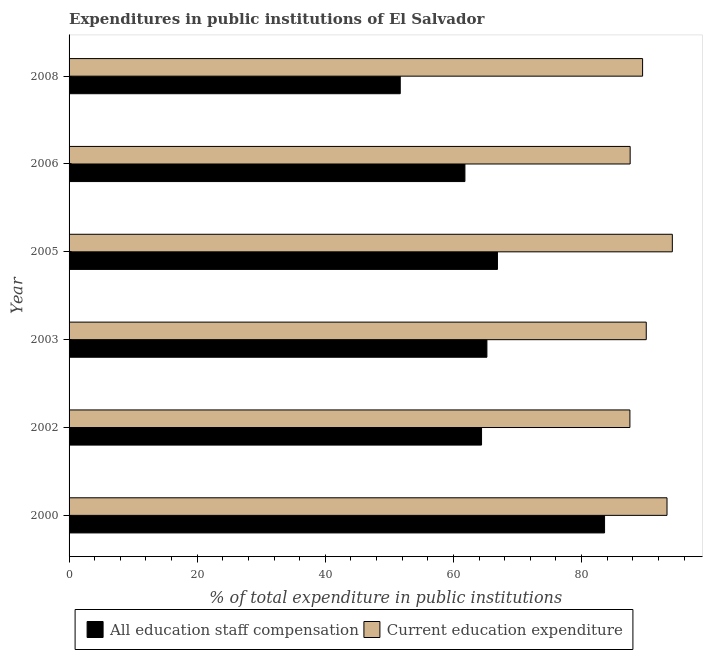How many different coloured bars are there?
Offer a very short reply. 2. Are the number of bars on each tick of the Y-axis equal?
Your answer should be compact. Yes. How many bars are there on the 3rd tick from the top?
Your response must be concise. 2. What is the label of the 5th group of bars from the top?
Your answer should be very brief. 2002. In how many cases, is the number of bars for a given year not equal to the number of legend labels?
Offer a terse response. 0. What is the expenditure in education in 2002?
Give a very brief answer. 87.54. Across all years, what is the maximum expenditure in staff compensation?
Make the answer very short. 83.58. Across all years, what is the minimum expenditure in staff compensation?
Your answer should be very brief. 51.69. In which year was the expenditure in staff compensation maximum?
Your response must be concise. 2000. In which year was the expenditure in education minimum?
Your answer should be very brief. 2002. What is the total expenditure in staff compensation in the graph?
Provide a succinct answer. 393.53. What is the difference between the expenditure in education in 2000 and that in 2008?
Give a very brief answer. 3.81. What is the difference between the expenditure in education in 2003 and the expenditure in staff compensation in 2000?
Ensure brevity in your answer.  6.51. What is the average expenditure in staff compensation per year?
Ensure brevity in your answer.  65.59. In the year 2002, what is the difference between the expenditure in education and expenditure in staff compensation?
Your answer should be very brief. 23.16. In how many years, is the expenditure in staff compensation greater than 72 %?
Your response must be concise. 1. What is the ratio of the expenditure in staff compensation in 2000 to that in 2006?
Provide a short and direct response. 1.35. Is the expenditure in staff compensation in 2000 less than that in 2006?
Offer a terse response. No. Is the difference between the expenditure in education in 2002 and 2008 greater than the difference between the expenditure in staff compensation in 2002 and 2008?
Ensure brevity in your answer.  No. What is the difference between the highest and the second highest expenditure in education?
Give a very brief answer. 0.83. What is the difference between the highest and the lowest expenditure in education?
Provide a short and direct response. 6.62. Is the sum of the expenditure in staff compensation in 2005 and 2006 greater than the maximum expenditure in education across all years?
Your answer should be compact. Yes. What does the 2nd bar from the top in 2008 represents?
Keep it short and to the point. All education staff compensation. What does the 1st bar from the bottom in 2000 represents?
Your response must be concise. All education staff compensation. How many bars are there?
Ensure brevity in your answer.  12. What is the title of the graph?
Offer a very short reply. Expenditures in public institutions of El Salvador. Does "GDP at market prices" appear as one of the legend labels in the graph?
Your answer should be very brief. No. What is the label or title of the X-axis?
Your answer should be compact. % of total expenditure in public institutions. What is the label or title of the Y-axis?
Provide a short and direct response. Year. What is the % of total expenditure in public institutions in All education staff compensation in 2000?
Offer a terse response. 83.58. What is the % of total expenditure in public institutions in Current education expenditure in 2000?
Provide a succinct answer. 93.33. What is the % of total expenditure in public institutions in All education staff compensation in 2002?
Offer a very short reply. 64.38. What is the % of total expenditure in public institutions in Current education expenditure in 2002?
Provide a short and direct response. 87.54. What is the % of total expenditure in public institutions in All education staff compensation in 2003?
Your answer should be compact. 65.22. What is the % of total expenditure in public institutions of Current education expenditure in 2003?
Keep it short and to the point. 90.09. What is the % of total expenditure in public institutions in All education staff compensation in 2005?
Offer a terse response. 66.86. What is the % of total expenditure in public institutions of Current education expenditure in 2005?
Provide a short and direct response. 94.16. What is the % of total expenditure in public institutions in All education staff compensation in 2006?
Keep it short and to the point. 61.79. What is the % of total expenditure in public institutions of Current education expenditure in 2006?
Offer a very short reply. 87.58. What is the % of total expenditure in public institutions in All education staff compensation in 2008?
Your response must be concise. 51.69. What is the % of total expenditure in public institutions of Current education expenditure in 2008?
Your answer should be compact. 89.52. Across all years, what is the maximum % of total expenditure in public institutions of All education staff compensation?
Ensure brevity in your answer.  83.58. Across all years, what is the maximum % of total expenditure in public institutions in Current education expenditure?
Offer a very short reply. 94.16. Across all years, what is the minimum % of total expenditure in public institutions of All education staff compensation?
Your answer should be very brief. 51.69. Across all years, what is the minimum % of total expenditure in public institutions of Current education expenditure?
Keep it short and to the point. 87.54. What is the total % of total expenditure in public institutions of All education staff compensation in the graph?
Make the answer very short. 393.53. What is the total % of total expenditure in public institutions of Current education expenditure in the graph?
Your answer should be very brief. 542.21. What is the difference between the % of total expenditure in public institutions in All education staff compensation in 2000 and that in 2002?
Offer a very short reply. 19.2. What is the difference between the % of total expenditure in public institutions in Current education expenditure in 2000 and that in 2002?
Provide a succinct answer. 5.79. What is the difference between the % of total expenditure in public institutions in All education staff compensation in 2000 and that in 2003?
Give a very brief answer. 18.36. What is the difference between the % of total expenditure in public institutions in Current education expenditure in 2000 and that in 2003?
Ensure brevity in your answer.  3.24. What is the difference between the % of total expenditure in public institutions in All education staff compensation in 2000 and that in 2005?
Offer a very short reply. 16.72. What is the difference between the % of total expenditure in public institutions in Current education expenditure in 2000 and that in 2005?
Make the answer very short. -0.83. What is the difference between the % of total expenditure in public institutions in All education staff compensation in 2000 and that in 2006?
Your answer should be compact. 21.8. What is the difference between the % of total expenditure in public institutions in Current education expenditure in 2000 and that in 2006?
Your answer should be compact. 5.75. What is the difference between the % of total expenditure in public institutions of All education staff compensation in 2000 and that in 2008?
Offer a terse response. 31.89. What is the difference between the % of total expenditure in public institutions of Current education expenditure in 2000 and that in 2008?
Your answer should be very brief. 3.81. What is the difference between the % of total expenditure in public institutions of All education staff compensation in 2002 and that in 2003?
Offer a terse response. -0.84. What is the difference between the % of total expenditure in public institutions in Current education expenditure in 2002 and that in 2003?
Make the answer very short. -2.55. What is the difference between the % of total expenditure in public institutions of All education staff compensation in 2002 and that in 2005?
Your answer should be compact. -2.48. What is the difference between the % of total expenditure in public institutions in Current education expenditure in 2002 and that in 2005?
Offer a very short reply. -6.62. What is the difference between the % of total expenditure in public institutions in All education staff compensation in 2002 and that in 2006?
Offer a terse response. 2.59. What is the difference between the % of total expenditure in public institutions in Current education expenditure in 2002 and that in 2006?
Provide a short and direct response. -0.04. What is the difference between the % of total expenditure in public institutions of All education staff compensation in 2002 and that in 2008?
Make the answer very short. 12.69. What is the difference between the % of total expenditure in public institutions in Current education expenditure in 2002 and that in 2008?
Make the answer very short. -1.98. What is the difference between the % of total expenditure in public institutions in All education staff compensation in 2003 and that in 2005?
Ensure brevity in your answer.  -1.65. What is the difference between the % of total expenditure in public institutions of Current education expenditure in 2003 and that in 2005?
Provide a succinct answer. -4.07. What is the difference between the % of total expenditure in public institutions in All education staff compensation in 2003 and that in 2006?
Keep it short and to the point. 3.43. What is the difference between the % of total expenditure in public institutions in Current education expenditure in 2003 and that in 2006?
Ensure brevity in your answer.  2.51. What is the difference between the % of total expenditure in public institutions in All education staff compensation in 2003 and that in 2008?
Provide a short and direct response. 13.53. What is the difference between the % of total expenditure in public institutions of Current education expenditure in 2003 and that in 2008?
Keep it short and to the point. 0.57. What is the difference between the % of total expenditure in public institutions of All education staff compensation in 2005 and that in 2006?
Provide a succinct answer. 5.08. What is the difference between the % of total expenditure in public institutions in Current education expenditure in 2005 and that in 2006?
Provide a succinct answer. 6.58. What is the difference between the % of total expenditure in public institutions of All education staff compensation in 2005 and that in 2008?
Your answer should be compact. 15.17. What is the difference between the % of total expenditure in public institutions of Current education expenditure in 2005 and that in 2008?
Make the answer very short. 4.64. What is the difference between the % of total expenditure in public institutions in All education staff compensation in 2006 and that in 2008?
Provide a short and direct response. 10.09. What is the difference between the % of total expenditure in public institutions of Current education expenditure in 2006 and that in 2008?
Your response must be concise. -1.94. What is the difference between the % of total expenditure in public institutions of All education staff compensation in 2000 and the % of total expenditure in public institutions of Current education expenditure in 2002?
Give a very brief answer. -3.96. What is the difference between the % of total expenditure in public institutions of All education staff compensation in 2000 and the % of total expenditure in public institutions of Current education expenditure in 2003?
Offer a very short reply. -6.51. What is the difference between the % of total expenditure in public institutions in All education staff compensation in 2000 and the % of total expenditure in public institutions in Current education expenditure in 2005?
Make the answer very short. -10.58. What is the difference between the % of total expenditure in public institutions of All education staff compensation in 2000 and the % of total expenditure in public institutions of Current education expenditure in 2006?
Offer a very short reply. -3.99. What is the difference between the % of total expenditure in public institutions in All education staff compensation in 2000 and the % of total expenditure in public institutions in Current education expenditure in 2008?
Offer a terse response. -5.94. What is the difference between the % of total expenditure in public institutions of All education staff compensation in 2002 and the % of total expenditure in public institutions of Current education expenditure in 2003?
Your response must be concise. -25.71. What is the difference between the % of total expenditure in public institutions of All education staff compensation in 2002 and the % of total expenditure in public institutions of Current education expenditure in 2005?
Keep it short and to the point. -29.78. What is the difference between the % of total expenditure in public institutions in All education staff compensation in 2002 and the % of total expenditure in public institutions in Current education expenditure in 2006?
Give a very brief answer. -23.2. What is the difference between the % of total expenditure in public institutions in All education staff compensation in 2002 and the % of total expenditure in public institutions in Current education expenditure in 2008?
Keep it short and to the point. -25.14. What is the difference between the % of total expenditure in public institutions of All education staff compensation in 2003 and the % of total expenditure in public institutions of Current education expenditure in 2005?
Your answer should be very brief. -28.94. What is the difference between the % of total expenditure in public institutions in All education staff compensation in 2003 and the % of total expenditure in public institutions in Current education expenditure in 2006?
Your response must be concise. -22.36. What is the difference between the % of total expenditure in public institutions in All education staff compensation in 2003 and the % of total expenditure in public institutions in Current education expenditure in 2008?
Your answer should be very brief. -24.3. What is the difference between the % of total expenditure in public institutions of All education staff compensation in 2005 and the % of total expenditure in public institutions of Current education expenditure in 2006?
Keep it short and to the point. -20.71. What is the difference between the % of total expenditure in public institutions of All education staff compensation in 2005 and the % of total expenditure in public institutions of Current education expenditure in 2008?
Keep it short and to the point. -22.65. What is the difference between the % of total expenditure in public institutions in All education staff compensation in 2006 and the % of total expenditure in public institutions in Current education expenditure in 2008?
Offer a terse response. -27.73. What is the average % of total expenditure in public institutions of All education staff compensation per year?
Ensure brevity in your answer.  65.59. What is the average % of total expenditure in public institutions of Current education expenditure per year?
Your answer should be very brief. 90.37. In the year 2000, what is the difference between the % of total expenditure in public institutions in All education staff compensation and % of total expenditure in public institutions in Current education expenditure?
Provide a succinct answer. -9.75. In the year 2002, what is the difference between the % of total expenditure in public institutions in All education staff compensation and % of total expenditure in public institutions in Current education expenditure?
Your answer should be compact. -23.16. In the year 2003, what is the difference between the % of total expenditure in public institutions in All education staff compensation and % of total expenditure in public institutions in Current education expenditure?
Your answer should be compact. -24.87. In the year 2005, what is the difference between the % of total expenditure in public institutions of All education staff compensation and % of total expenditure in public institutions of Current education expenditure?
Give a very brief answer. -27.3. In the year 2006, what is the difference between the % of total expenditure in public institutions of All education staff compensation and % of total expenditure in public institutions of Current education expenditure?
Keep it short and to the point. -25.79. In the year 2008, what is the difference between the % of total expenditure in public institutions of All education staff compensation and % of total expenditure in public institutions of Current education expenditure?
Keep it short and to the point. -37.83. What is the ratio of the % of total expenditure in public institutions in All education staff compensation in 2000 to that in 2002?
Make the answer very short. 1.3. What is the ratio of the % of total expenditure in public institutions in Current education expenditure in 2000 to that in 2002?
Your response must be concise. 1.07. What is the ratio of the % of total expenditure in public institutions of All education staff compensation in 2000 to that in 2003?
Offer a terse response. 1.28. What is the ratio of the % of total expenditure in public institutions in Current education expenditure in 2000 to that in 2003?
Ensure brevity in your answer.  1.04. What is the ratio of the % of total expenditure in public institutions in All education staff compensation in 2000 to that in 2006?
Your response must be concise. 1.35. What is the ratio of the % of total expenditure in public institutions in Current education expenditure in 2000 to that in 2006?
Offer a terse response. 1.07. What is the ratio of the % of total expenditure in public institutions in All education staff compensation in 2000 to that in 2008?
Give a very brief answer. 1.62. What is the ratio of the % of total expenditure in public institutions in Current education expenditure in 2000 to that in 2008?
Your answer should be very brief. 1.04. What is the ratio of the % of total expenditure in public institutions of All education staff compensation in 2002 to that in 2003?
Your answer should be compact. 0.99. What is the ratio of the % of total expenditure in public institutions in Current education expenditure in 2002 to that in 2003?
Provide a short and direct response. 0.97. What is the ratio of the % of total expenditure in public institutions of All education staff compensation in 2002 to that in 2005?
Provide a short and direct response. 0.96. What is the ratio of the % of total expenditure in public institutions in Current education expenditure in 2002 to that in 2005?
Give a very brief answer. 0.93. What is the ratio of the % of total expenditure in public institutions in All education staff compensation in 2002 to that in 2006?
Your answer should be compact. 1.04. What is the ratio of the % of total expenditure in public institutions of Current education expenditure in 2002 to that in 2006?
Offer a terse response. 1. What is the ratio of the % of total expenditure in public institutions of All education staff compensation in 2002 to that in 2008?
Your answer should be very brief. 1.25. What is the ratio of the % of total expenditure in public institutions in Current education expenditure in 2002 to that in 2008?
Offer a very short reply. 0.98. What is the ratio of the % of total expenditure in public institutions of All education staff compensation in 2003 to that in 2005?
Your response must be concise. 0.98. What is the ratio of the % of total expenditure in public institutions of Current education expenditure in 2003 to that in 2005?
Keep it short and to the point. 0.96. What is the ratio of the % of total expenditure in public institutions in All education staff compensation in 2003 to that in 2006?
Keep it short and to the point. 1.06. What is the ratio of the % of total expenditure in public institutions in Current education expenditure in 2003 to that in 2006?
Ensure brevity in your answer.  1.03. What is the ratio of the % of total expenditure in public institutions of All education staff compensation in 2003 to that in 2008?
Ensure brevity in your answer.  1.26. What is the ratio of the % of total expenditure in public institutions in Current education expenditure in 2003 to that in 2008?
Offer a terse response. 1.01. What is the ratio of the % of total expenditure in public institutions in All education staff compensation in 2005 to that in 2006?
Your answer should be very brief. 1.08. What is the ratio of the % of total expenditure in public institutions of Current education expenditure in 2005 to that in 2006?
Your answer should be very brief. 1.08. What is the ratio of the % of total expenditure in public institutions in All education staff compensation in 2005 to that in 2008?
Keep it short and to the point. 1.29. What is the ratio of the % of total expenditure in public institutions in Current education expenditure in 2005 to that in 2008?
Offer a terse response. 1.05. What is the ratio of the % of total expenditure in public institutions of All education staff compensation in 2006 to that in 2008?
Make the answer very short. 1.2. What is the ratio of the % of total expenditure in public institutions in Current education expenditure in 2006 to that in 2008?
Give a very brief answer. 0.98. What is the difference between the highest and the second highest % of total expenditure in public institutions of All education staff compensation?
Keep it short and to the point. 16.72. What is the difference between the highest and the second highest % of total expenditure in public institutions of Current education expenditure?
Ensure brevity in your answer.  0.83. What is the difference between the highest and the lowest % of total expenditure in public institutions in All education staff compensation?
Make the answer very short. 31.89. What is the difference between the highest and the lowest % of total expenditure in public institutions of Current education expenditure?
Keep it short and to the point. 6.62. 